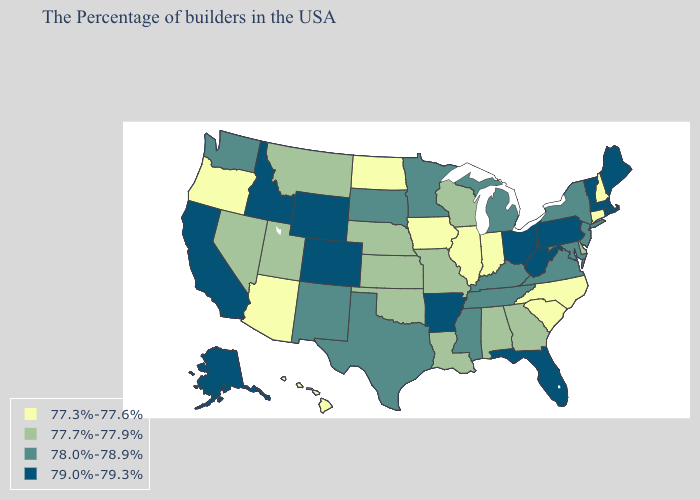What is the value of Missouri?
Keep it brief. 77.7%-77.9%. What is the highest value in states that border Delaware?
Keep it brief. 79.0%-79.3%. What is the highest value in states that border Wyoming?
Concise answer only. 79.0%-79.3%. Among the states that border Tennessee , which have the lowest value?
Give a very brief answer. North Carolina. Which states have the lowest value in the MidWest?
Give a very brief answer. Indiana, Illinois, Iowa, North Dakota. Does Tennessee have the lowest value in the USA?
Keep it brief. No. Does California have the same value as Vermont?
Keep it brief. Yes. What is the value of Louisiana?
Quick response, please. 77.7%-77.9%. What is the value of Pennsylvania?
Write a very short answer. 79.0%-79.3%. Does the map have missing data?
Write a very short answer. No. What is the value of Kentucky?
Short answer required. 78.0%-78.9%. Name the states that have a value in the range 77.3%-77.6%?
Concise answer only. New Hampshire, Connecticut, North Carolina, South Carolina, Indiana, Illinois, Iowa, North Dakota, Arizona, Oregon, Hawaii. Does Maine have the same value as Massachusetts?
Short answer required. Yes. Which states have the lowest value in the Northeast?
Short answer required. New Hampshire, Connecticut. What is the lowest value in the West?
Short answer required. 77.3%-77.6%. 